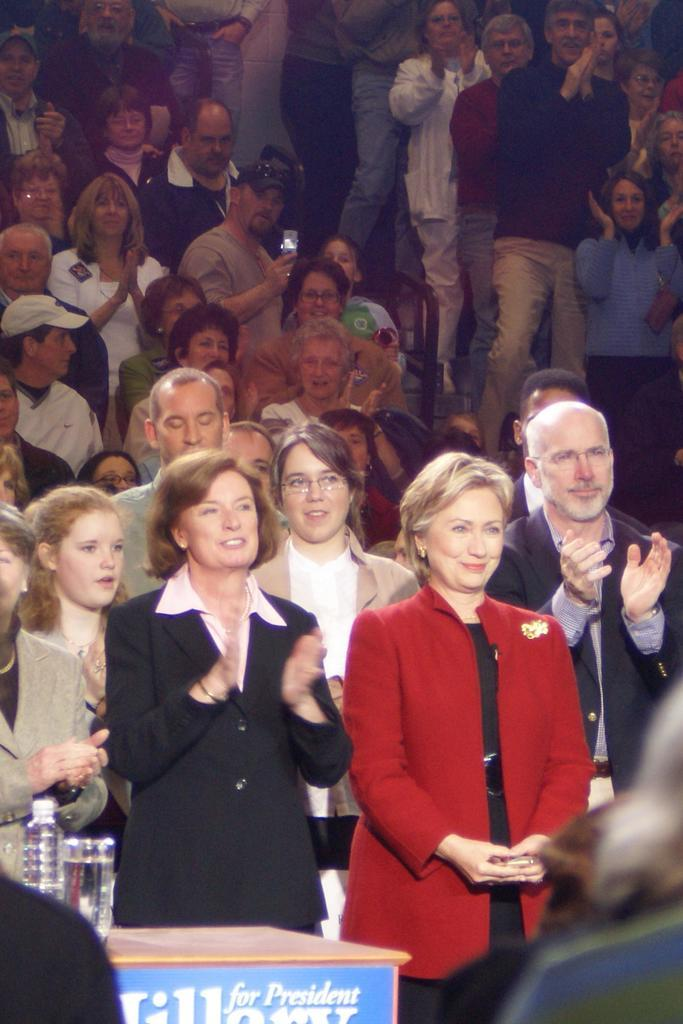What can be seen in the image involving people? There are persons standing in the image. What type of furniture is present in the image? There is a desk in the image. What items are on the desk? A glass and a water bottle are on the desk. Can you describe the background of the image? There are other persons visible in the background of the image. What type of apple is being used as a reward for the persons in the image? There is no apple present in the image, and no rewards are being given to the persons. 